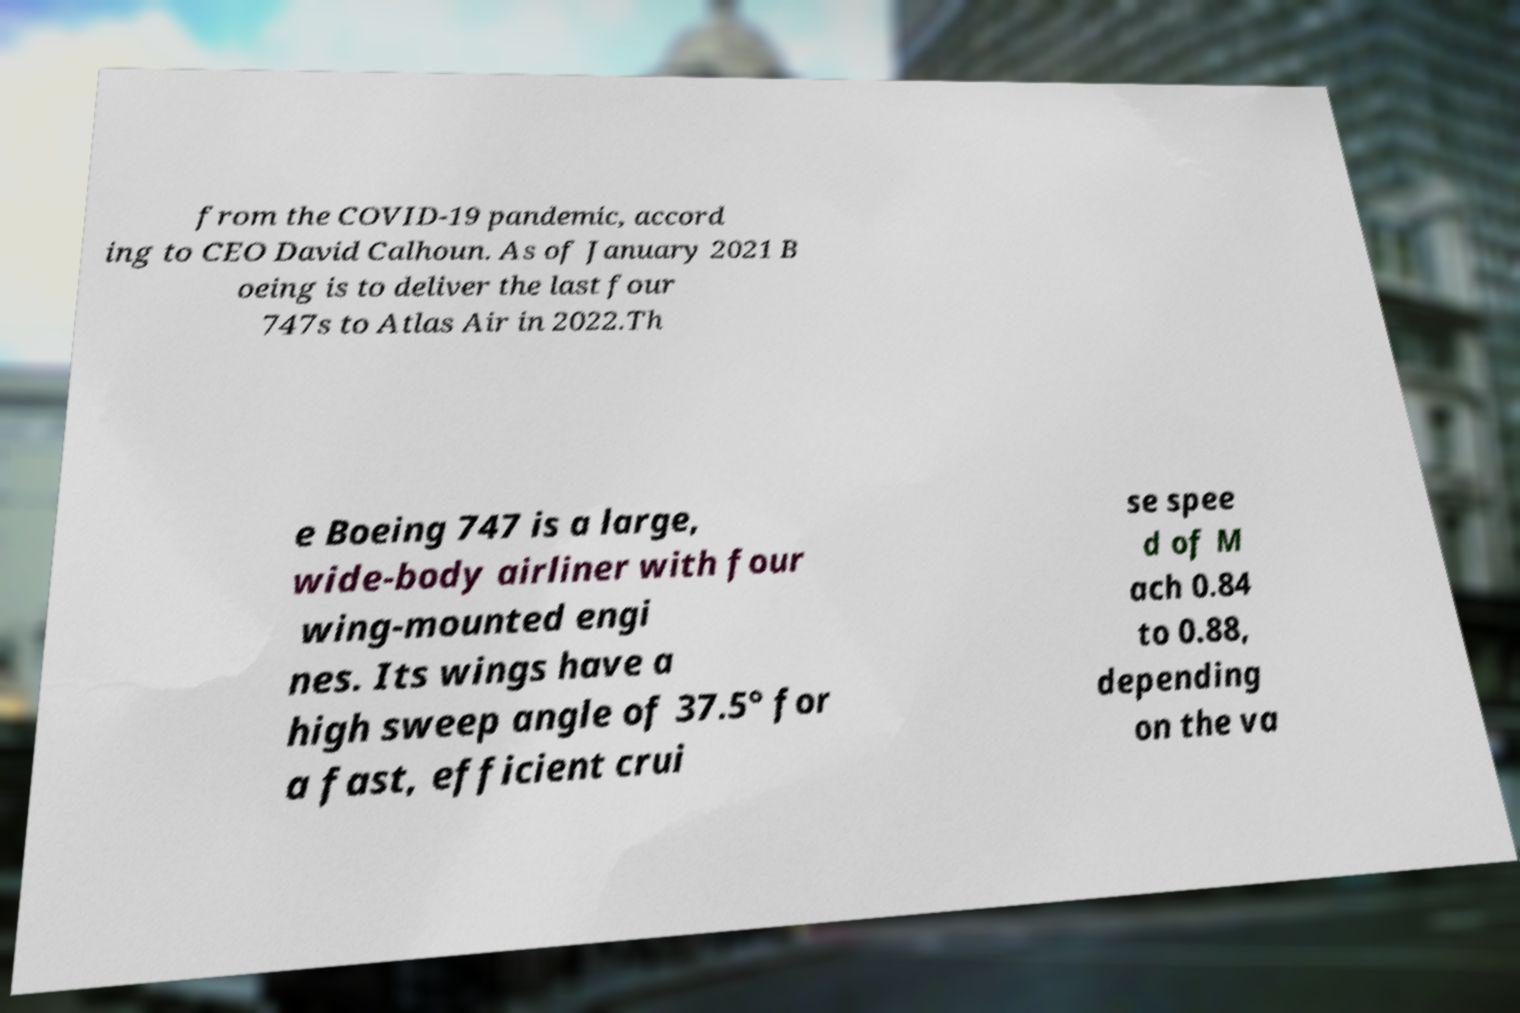I need the written content from this picture converted into text. Can you do that? from the COVID-19 pandemic, accord ing to CEO David Calhoun. As of January 2021 B oeing is to deliver the last four 747s to Atlas Air in 2022.Th e Boeing 747 is a large, wide-body airliner with four wing-mounted engi nes. Its wings have a high sweep angle of 37.5° for a fast, efficient crui se spee d of M ach 0.84 to 0.88, depending on the va 